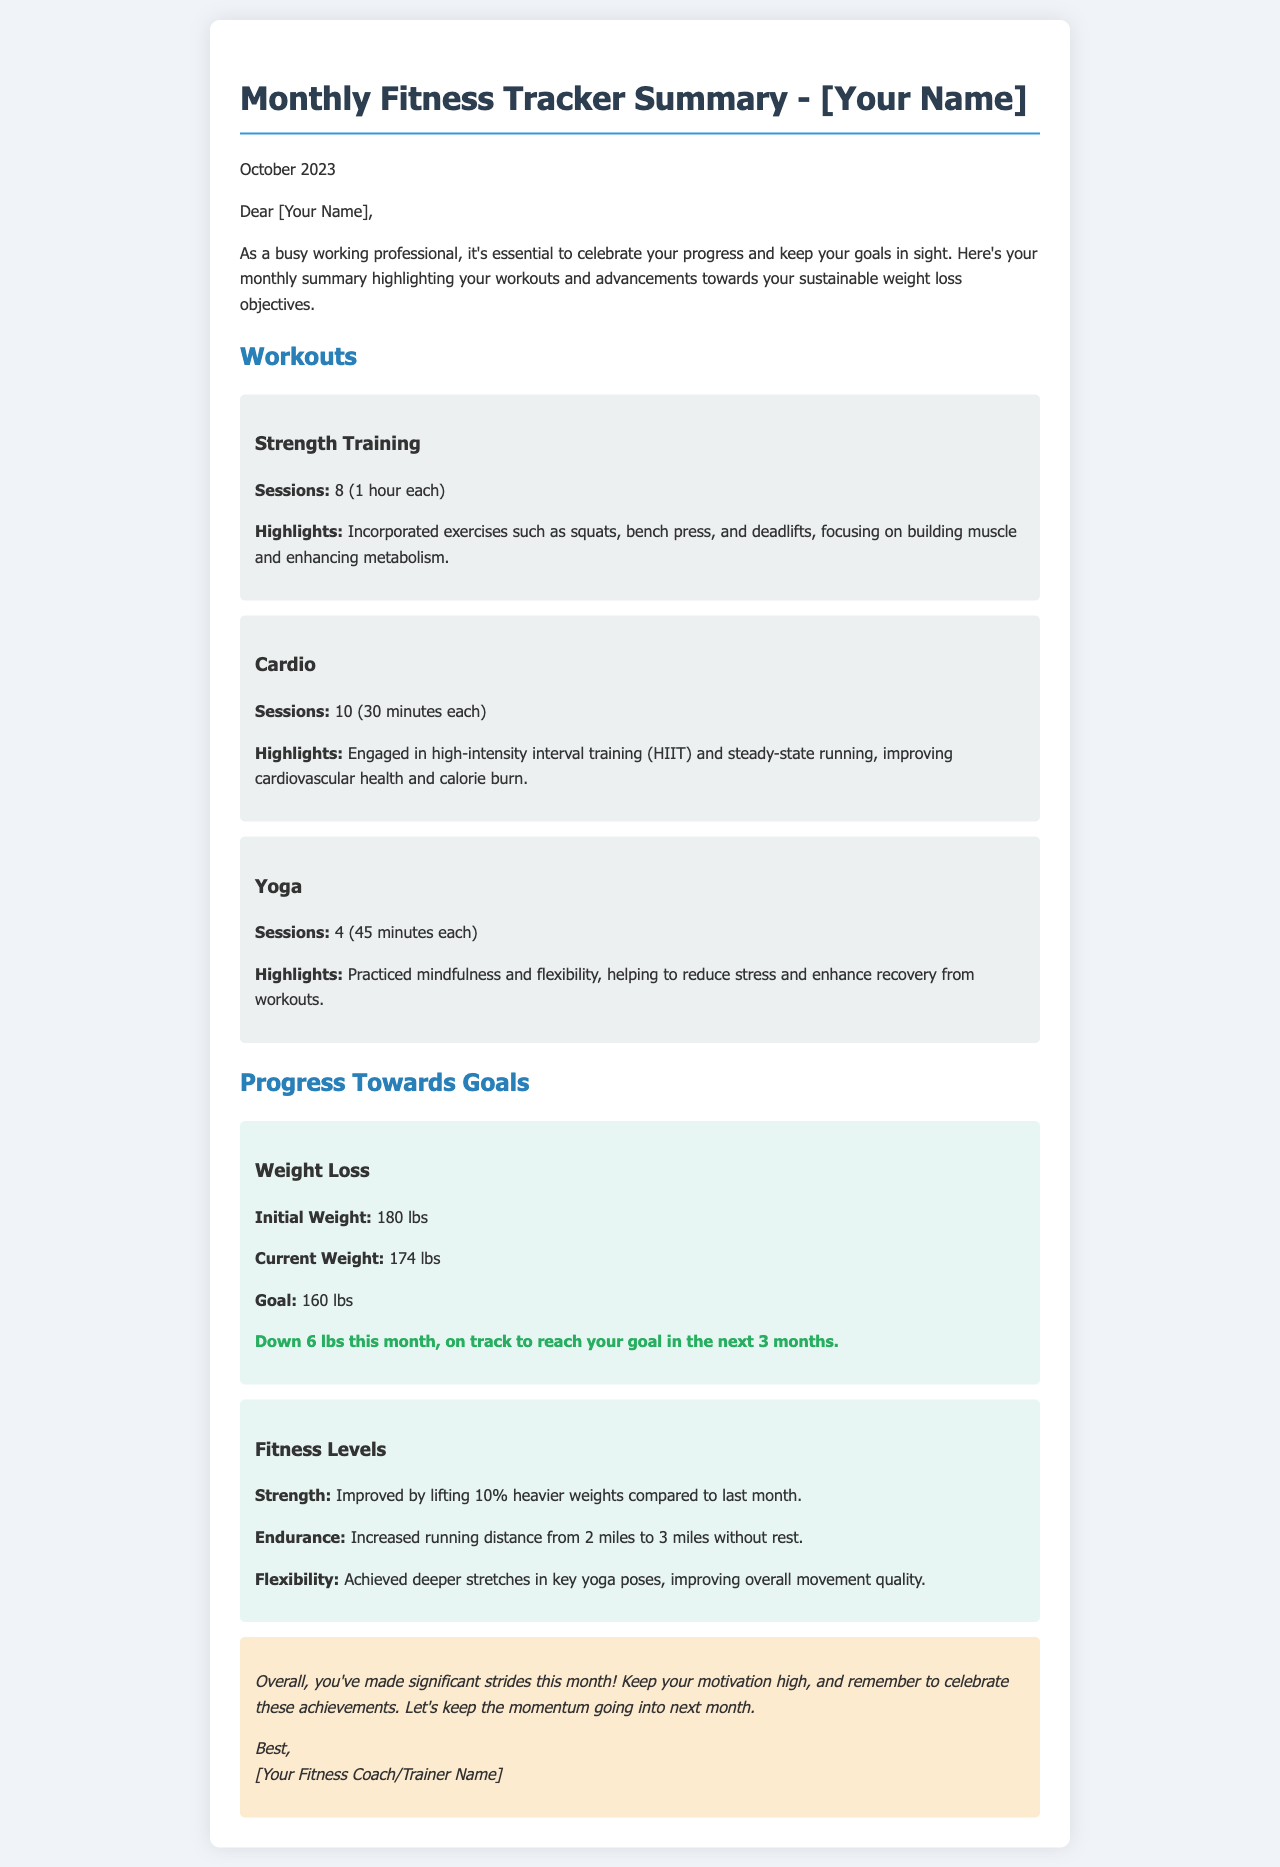What is the initial weight? The initial weight is stated in the progress section of the document, which is 180 lbs.
Answer: 180 lbs How many strength training sessions were completed? The total number of strength training sessions is highlighted directly in the workouts section, which is 8.
Answer: 8 What is the current weight? The current weight can be found in the progress section of the document, and it is 174 lbs.
Answer: 174 lbs What improvement was made in the endurance level? The endurance improvement is noted by the increased running distance, which is from 2 miles to 3 miles.
Answer: 3 miles What was the goal weight? The goal weight is listed in the progress section, which states the goal is 160 lbs.
Answer: 160 lbs What type of training was done for cardio? The document specifies that high-intensity interval training (HIIT) and steady-state running were the types of cardio performed.
Answer: HIIT and steady-state running How much weight was lost this month? The weight loss for the month is clearly stated in the progress section, which is down 6 lbs.
Answer: 6 lbs How many yoga sessions were practiced? The total number of yoga sessions is detailed in the workouts section, which counts as 4 sessions.
Answer: 4 What percentage increase was achieved in strength? The document notes that strength improved by lifting 10% heavier weights compared to last month.
Answer: 10% What is the overall conclusion about this month's progress? The conclusion emphasizes making significant strides and keeping motivation high to celebrate achievements.
Answer: Significant strides made 